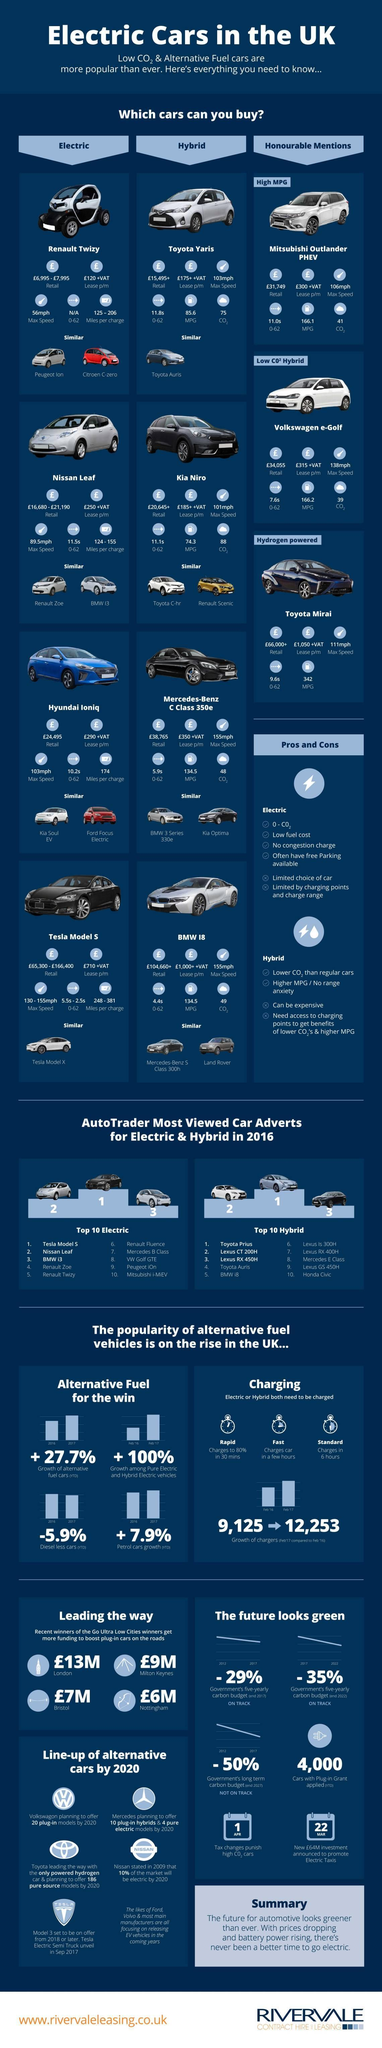How many cars are similar to Testa Model 5?
Answer the question with a short phrase. 1 Which is the AutoTrader most viewed hybrid car in 2106? Toyota Prius What is the maximum speed of Nissan Leaf? 89.5mph How many cars are similar to BMW 18? 2 Which is the AutoTrader most viewed electric car in 2106? Testa Model S What is the color of Testa Model S-red, white, silver, or black? black 